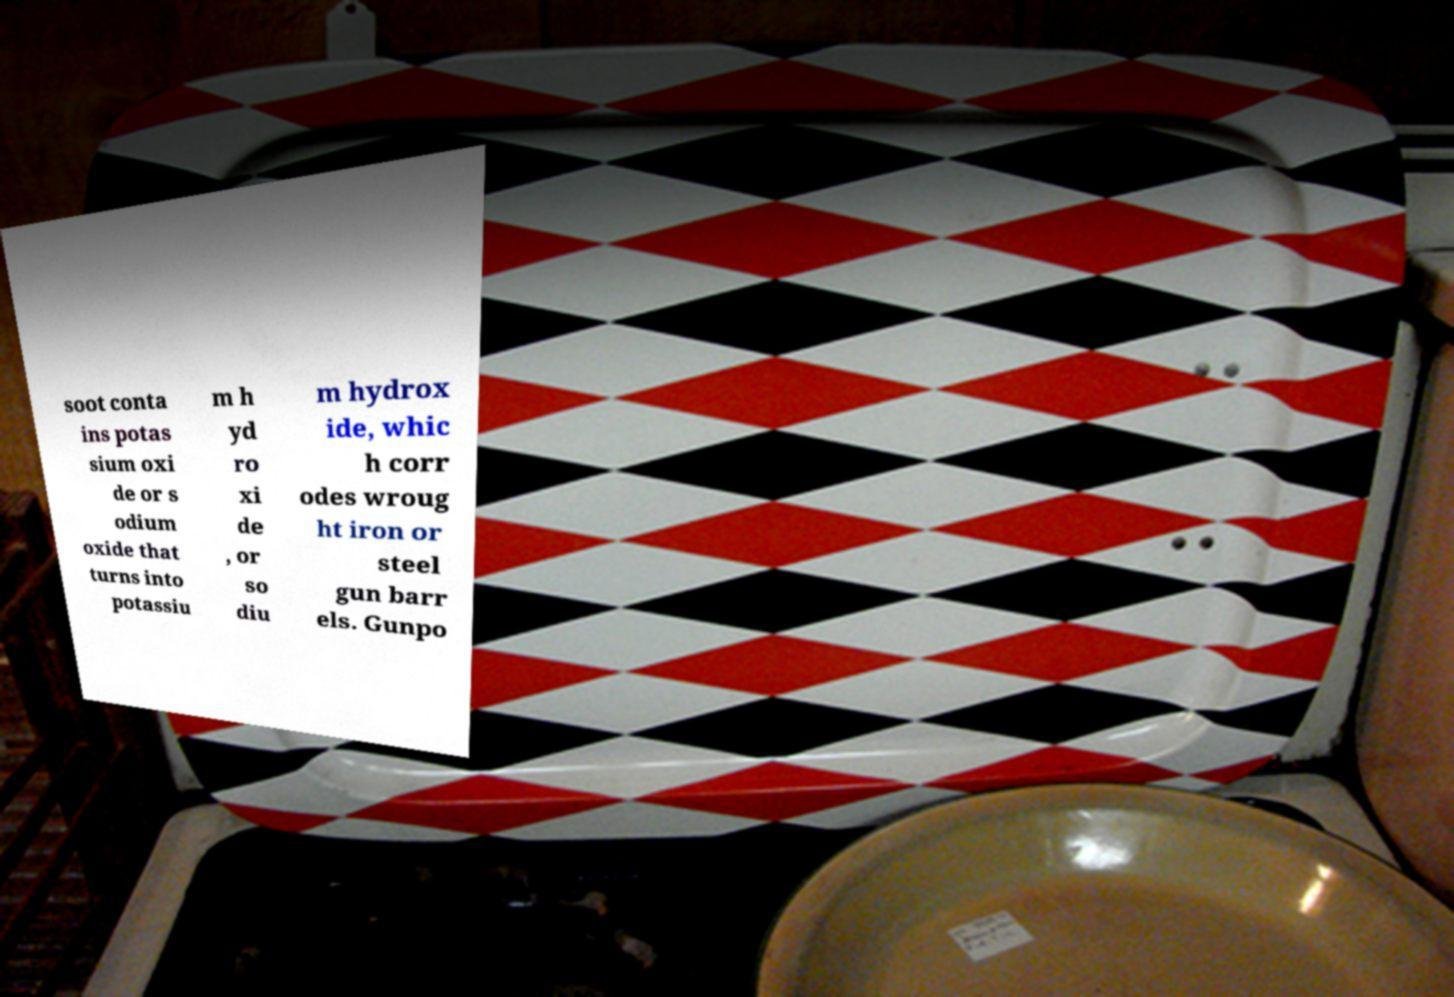Could you extract and type out the text from this image? soot conta ins potas sium oxi de or s odium oxide that turns into potassiu m h yd ro xi de , or so diu m hydrox ide, whic h corr odes wroug ht iron or steel gun barr els. Gunpo 